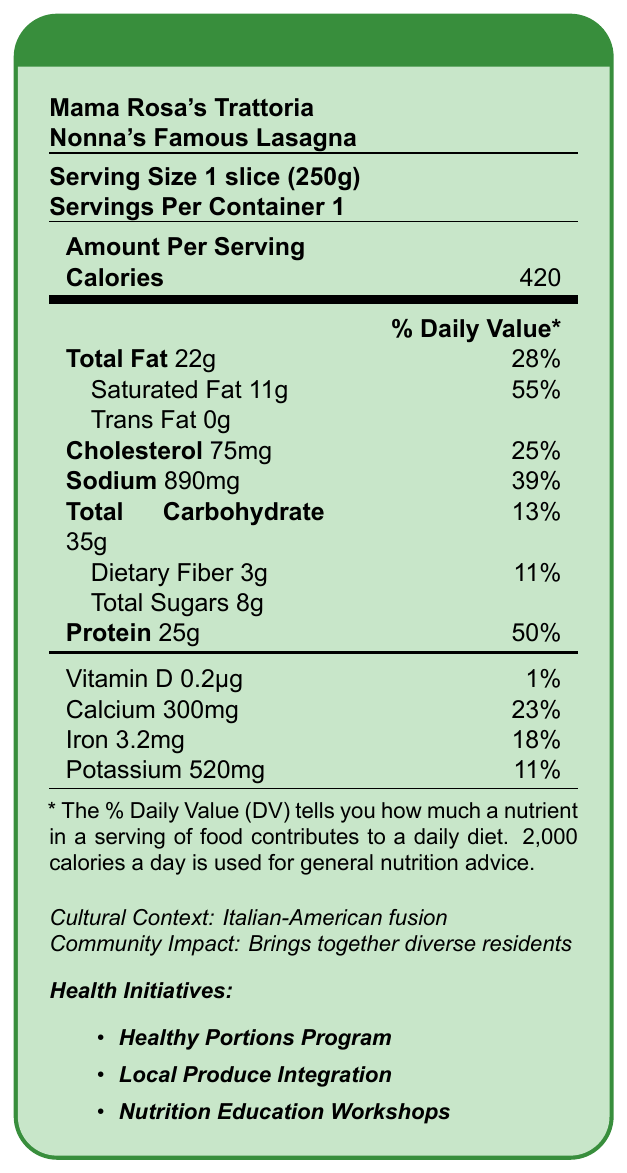What is the serving size of Nonna's Famous Lasagna? The serving size is clearly stated at the beginning of the document as "Serving Size 1 slice (250g)".
Answer: 1 slice (250g) How many calories are in one serving of Nonna's Famous Lasagna? The document lists the calories amount per serving as 420.
Answer: 420 What percentage of the daily value for saturated fat does one serving of lasagna provide? The document specifies that one serving contains 55% of the daily value for saturated fat.
Answer: 55% What community initiative aims to reduce calorie intake by offering smaller portions? The "Healthy Portions Program" is mentioned under Health Initiatives as one focusing on reducing calorie intake by offering smaller portions.
Answer: Healthy Portions Program Can you list the positive nutritional aspects of Nonna's Famous Lasagna mentioned in the document? The positive aspects are mentioned in the health implications section.
Answer: Good source of protein for muscle health, Provides calcium for bone strength, Contains iron to support blood health How much sodium does one serving of lasagna contain? The sodium content per serving is listed as 890mg in the document.
Answer: 890mg Which mineral found in Nonna's Famous Lasagna supports blood health? The document highlights iron, which supports blood health, in the positive aspects of the health implications.
Answer: Iron What cultural significance does Nonna's Famous Lasagna have according to the document? A. Represents traditional Italian cuisine B. Represents the fusion of traditional Italian cuisine with local ingredients and tastes C. Represents modern Italian cooking The document states that it "represents the fusion of traditional Italian cuisine with local ingredients and tastes."
Answer: B What is the impact of Nonna's Famous Lasagna on the community, as noted in the document? The community impact section notes that the dish brings together diverse residents through shared appreciation of comfort food.
Answer: Brings together diverse residents through shared appreciation of comfort food What percentage of the daily value for calcium does one serving of lasagna provide? A. 11% B. 18% C. 23% D. 39% The document notes that one serving of lasagna provides 23% of the daily value for calcium.
Answer: C Is the lasagna described as having any trans fat? The document specifies that the trans fat content is 0 grams.
Answer: No How many grams of protein are in a serving of Nonna's Famous Lasagna? The document lists the protein content as 25 grams per serving.
Answer: 25 grams Summarize the document in one sentence. The document includes comprehensive nutritional information, cultural context, health implications, community health initiatives, and actions by the neighborhood association related to the lasagna.
Answer: The document provides the nutritional facts of Nonna's Famous Lasagna from Mama Rosa's Trattoria, detailing serving size, calorie content, nutritional values, cultural context, health implications, community health initiatives, and actions by the neighborhood association. How does the dish's sodium content potentially impact health according to the document? The document mentions that the high sodium content can potentially impact blood pressure.
Answer: Potentially impacting blood pressure What is the primary goal of the Local Produce Integration initiative? The goal of this initiative is to work with Mama Rosa's to incorporate more locally-sourced vegetables into their dishes.
Answer: To incorporate more locally-sourced vegetables into dishes What is the feedback from the community about Nonna's Famous Lasagna? The document does not provide detailed community feedback on the lasagna.
Answer: Not enough information What vitamin, although present in very small quantities, is included in the nutrition facts? The document lists vitamin D as being present in the amount of 0.2µg, which is 1% of the daily value.
Answer: Vitamin D How many servings are in one container? The document specifies that there is 1 serving per container.
Answer: 1 